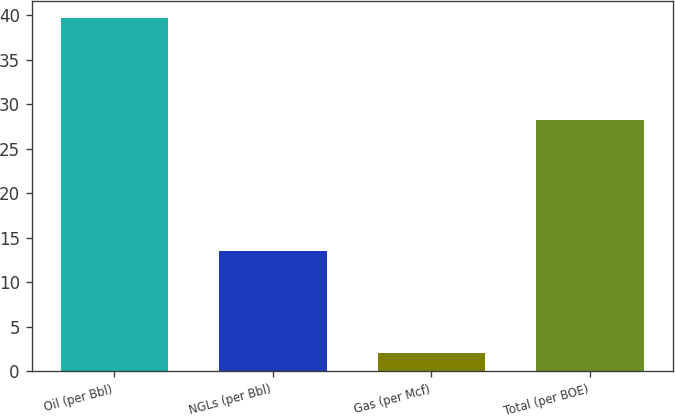Convert chart to OTSL. <chart><loc_0><loc_0><loc_500><loc_500><bar_chart><fcel>Oil (per Bbl)<fcel>NGLs (per Bbl)<fcel>Gas (per Mcf)<fcel>Total (per BOE)<nl><fcel>39.65<fcel>13.49<fcel>2.11<fcel>28.25<nl></chart> 